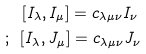Convert formula to latex. <formula><loc_0><loc_0><loc_500><loc_500>[ I _ { \lambda } , I _ { \mu } ] = c _ { \lambda \mu \nu } I _ { \nu } \, \\ ; \, \ [ I _ { \lambda } , J _ { \mu } ] = c _ { \lambda \mu \nu } J _ { \nu }</formula> 